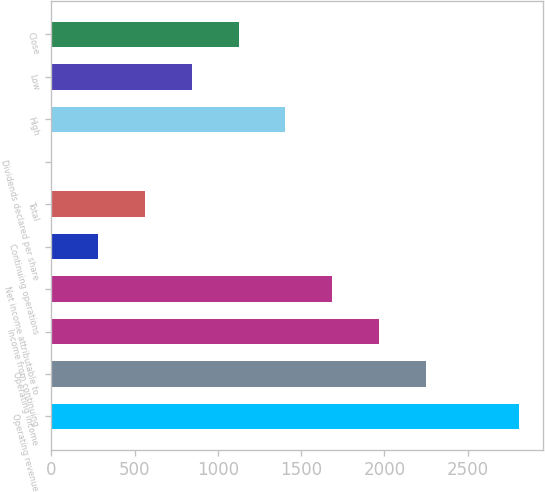<chart> <loc_0><loc_0><loc_500><loc_500><bar_chart><fcel>Operating revenue<fcel>Operating income<fcel>Income from continuing<fcel>Net income attributable to<fcel>Continuing operations<fcel>Total<fcel>Dividends declared per share<fcel>High<fcel>Low<fcel>Close<nl><fcel>2810<fcel>2248.08<fcel>1967.11<fcel>1686.14<fcel>281.29<fcel>562.26<fcel>0.32<fcel>1405.17<fcel>843.23<fcel>1124.2<nl></chart> 